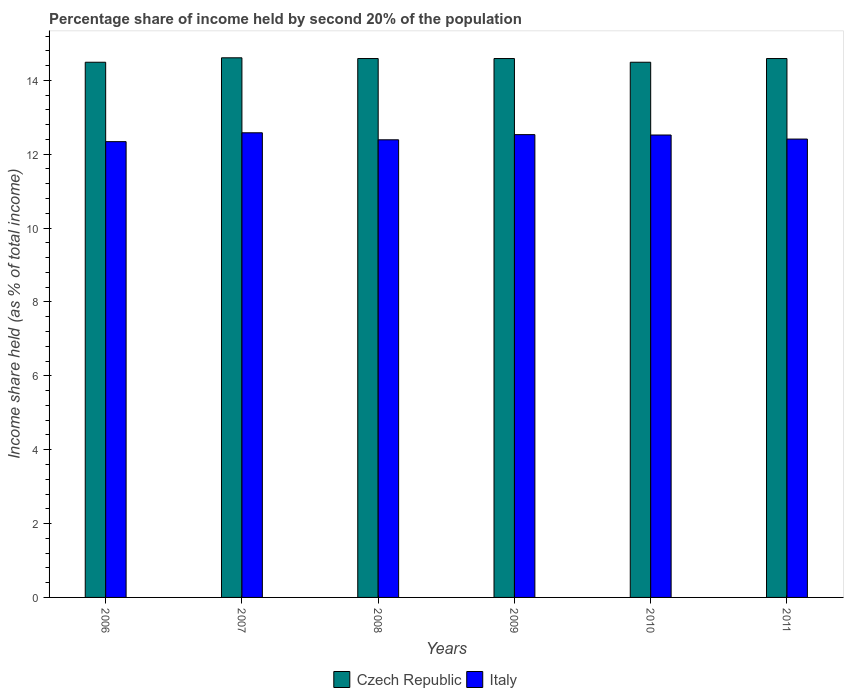How many different coloured bars are there?
Your answer should be compact. 2. How many groups of bars are there?
Keep it short and to the point. 6. Are the number of bars per tick equal to the number of legend labels?
Make the answer very short. Yes. How many bars are there on the 3rd tick from the right?
Ensure brevity in your answer.  2. What is the share of income held by second 20% of the population in Italy in 2011?
Your response must be concise. 12.41. Across all years, what is the maximum share of income held by second 20% of the population in Czech Republic?
Give a very brief answer. 14.61. Across all years, what is the minimum share of income held by second 20% of the population in Italy?
Offer a very short reply. 12.34. In which year was the share of income held by second 20% of the population in Italy maximum?
Provide a succinct answer. 2007. What is the total share of income held by second 20% of the population in Czech Republic in the graph?
Your answer should be compact. 87.36. What is the difference between the share of income held by second 20% of the population in Czech Republic in 2010 and the share of income held by second 20% of the population in Italy in 2006?
Give a very brief answer. 2.15. What is the average share of income held by second 20% of the population in Italy per year?
Give a very brief answer. 12.46. In the year 2007, what is the difference between the share of income held by second 20% of the population in Italy and share of income held by second 20% of the population in Czech Republic?
Make the answer very short. -2.03. In how many years, is the share of income held by second 20% of the population in Italy greater than 1.2000000000000002 %?
Provide a succinct answer. 6. What is the ratio of the share of income held by second 20% of the population in Czech Republic in 2008 to that in 2009?
Offer a very short reply. 1. Is the share of income held by second 20% of the population in Czech Republic in 2008 less than that in 2010?
Your answer should be compact. No. Is the difference between the share of income held by second 20% of the population in Italy in 2007 and 2010 greater than the difference between the share of income held by second 20% of the population in Czech Republic in 2007 and 2010?
Your answer should be compact. No. What is the difference between the highest and the second highest share of income held by second 20% of the population in Czech Republic?
Offer a terse response. 0.02. What is the difference between the highest and the lowest share of income held by second 20% of the population in Czech Republic?
Offer a very short reply. 0.12. What does the 2nd bar from the left in 2009 represents?
Keep it short and to the point. Italy. What does the 2nd bar from the right in 2006 represents?
Your response must be concise. Czech Republic. How many bars are there?
Offer a terse response. 12. Are all the bars in the graph horizontal?
Offer a terse response. No. Are the values on the major ticks of Y-axis written in scientific E-notation?
Give a very brief answer. No. Does the graph contain any zero values?
Provide a succinct answer. No. Does the graph contain grids?
Provide a short and direct response. No. How many legend labels are there?
Provide a short and direct response. 2. How are the legend labels stacked?
Offer a terse response. Horizontal. What is the title of the graph?
Make the answer very short. Percentage share of income held by second 20% of the population. Does "Nigeria" appear as one of the legend labels in the graph?
Your response must be concise. No. What is the label or title of the Y-axis?
Make the answer very short. Income share held (as % of total income). What is the Income share held (as % of total income) of Czech Republic in 2006?
Provide a succinct answer. 14.49. What is the Income share held (as % of total income) in Italy in 2006?
Offer a terse response. 12.34. What is the Income share held (as % of total income) of Czech Republic in 2007?
Your response must be concise. 14.61. What is the Income share held (as % of total income) of Italy in 2007?
Provide a short and direct response. 12.58. What is the Income share held (as % of total income) in Czech Republic in 2008?
Ensure brevity in your answer.  14.59. What is the Income share held (as % of total income) in Italy in 2008?
Your answer should be compact. 12.39. What is the Income share held (as % of total income) of Czech Republic in 2009?
Keep it short and to the point. 14.59. What is the Income share held (as % of total income) in Italy in 2009?
Provide a short and direct response. 12.53. What is the Income share held (as % of total income) in Czech Republic in 2010?
Provide a short and direct response. 14.49. What is the Income share held (as % of total income) in Italy in 2010?
Make the answer very short. 12.52. What is the Income share held (as % of total income) in Czech Republic in 2011?
Provide a succinct answer. 14.59. What is the Income share held (as % of total income) in Italy in 2011?
Make the answer very short. 12.41. Across all years, what is the maximum Income share held (as % of total income) of Czech Republic?
Your answer should be very brief. 14.61. Across all years, what is the maximum Income share held (as % of total income) in Italy?
Your answer should be compact. 12.58. Across all years, what is the minimum Income share held (as % of total income) of Czech Republic?
Offer a very short reply. 14.49. Across all years, what is the minimum Income share held (as % of total income) of Italy?
Ensure brevity in your answer.  12.34. What is the total Income share held (as % of total income) in Czech Republic in the graph?
Ensure brevity in your answer.  87.36. What is the total Income share held (as % of total income) in Italy in the graph?
Your answer should be very brief. 74.77. What is the difference between the Income share held (as % of total income) in Czech Republic in 2006 and that in 2007?
Offer a very short reply. -0.12. What is the difference between the Income share held (as % of total income) in Italy in 2006 and that in 2007?
Your answer should be compact. -0.24. What is the difference between the Income share held (as % of total income) in Italy in 2006 and that in 2008?
Give a very brief answer. -0.05. What is the difference between the Income share held (as % of total income) of Czech Republic in 2006 and that in 2009?
Give a very brief answer. -0.1. What is the difference between the Income share held (as % of total income) in Italy in 2006 and that in 2009?
Offer a terse response. -0.19. What is the difference between the Income share held (as % of total income) of Italy in 2006 and that in 2010?
Your answer should be compact. -0.18. What is the difference between the Income share held (as % of total income) in Czech Republic in 2006 and that in 2011?
Make the answer very short. -0.1. What is the difference between the Income share held (as % of total income) in Italy in 2006 and that in 2011?
Ensure brevity in your answer.  -0.07. What is the difference between the Income share held (as % of total income) in Czech Republic in 2007 and that in 2008?
Your answer should be compact. 0.02. What is the difference between the Income share held (as % of total income) of Italy in 2007 and that in 2008?
Your answer should be compact. 0.19. What is the difference between the Income share held (as % of total income) in Czech Republic in 2007 and that in 2009?
Offer a terse response. 0.02. What is the difference between the Income share held (as % of total income) in Czech Republic in 2007 and that in 2010?
Provide a short and direct response. 0.12. What is the difference between the Income share held (as % of total income) in Czech Republic in 2007 and that in 2011?
Offer a terse response. 0.02. What is the difference between the Income share held (as % of total income) in Italy in 2007 and that in 2011?
Your answer should be very brief. 0.17. What is the difference between the Income share held (as % of total income) in Czech Republic in 2008 and that in 2009?
Your answer should be compact. 0. What is the difference between the Income share held (as % of total income) of Italy in 2008 and that in 2009?
Provide a short and direct response. -0.14. What is the difference between the Income share held (as % of total income) in Italy in 2008 and that in 2010?
Offer a terse response. -0.13. What is the difference between the Income share held (as % of total income) in Italy in 2008 and that in 2011?
Your answer should be very brief. -0.02. What is the difference between the Income share held (as % of total income) of Czech Republic in 2009 and that in 2010?
Give a very brief answer. 0.1. What is the difference between the Income share held (as % of total income) in Italy in 2009 and that in 2010?
Provide a short and direct response. 0.01. What is the difference between the Income share held (as % of total income) of Czech Republic in 2009 and that in 2011?
Provide a succinct answer. 0. What is the difference between the Income share held (as % of total income) of Italy in 2009 and that in 2011?
Make the answer very short. 0.12. What is the difference between the Income share held (as % of total income) of Italy in 2010 and that in 2011?
Offer a terse response. 0.11. What is the difference between the Income share held (as % of total income) of Czech Republic in 2006 and the Income share held (as % of total income) of Italy in 2007?
Keep it short and to the point. 1.91. What is the difference between the Income share held (as % of total income) of Czech Republic in 2006 and the Income share held (as % of total income) of Italy in 2009?
Your answer should be very brief. 1.96. What is the difference between the Income share held (as % of total income) of Czech Republic in 2006 and the Income share held (as % of total income) of Italy in 2010?
Offer a terse response. 1.97. What is the difference between the Income share held (as % of total income) in Czech Republic in 2006 and the Income share held (as % of total income) in Italy in 2011?
Offer a terse response. 2.08. What is the difference between the Income share held (as % of total income) in Czech Republic in 2007 and the Income share held (as % of total income) in Italy in 2008?
Give a very brief answer. 2.22. What is the difference between the Income share held (as % of total income) of Czech Republic in 2007 and the Income share held (as % of total income) of Italy in 2009?
Provide a succinct answer. 2.08. What is the difference between the Income share held (as % of total income) of Czech Republic in 2007 and the Income share held (as % of total income) of Italy in 2010?
Make the answer very short. 2.09. What is the difference between the Income share held (as % of total income) of Czech Republic in 2008 and the Income share held (as % of total income) of Italy in 2009?
Provide a short and direct response. 2.06. What is the difference between the Income share held (as % of total income) in Czech Republic in 2008 and the Income share held (as % of total income) in Italy in 2010?
Provide a succinct answer. 2.07. What is the difference between the Income share held (as % of total income) in Czech Republic in 2008 and the Income share held (as % of total income) in Italy in 2011?
Give a very brief answer. 2.18. What is the difference between the Income share held (as % of total income) in Czech Republic in 2009 and the Income share held (as % of total income) in Italy in 2010?
Ensure brevity in your answer.  2.07. What is the difference between the Income share held (as % of total income) in Czech Republic in 2009 and the Income share held (as % of total income) in Italy in 2011?
Make the answer very short. 2.18. What is the difference between the Income share held (as % of total income) in Czech Republic in 2010 and the Income share held (as % of total income) in Italy in 2011?
Your answer should be compact. 2.08. What is the average Income share held (as % of total income) in Czech Republic per year?
Give a very brief answer. 14.56. What is the average Income share held (as % of total income) in Italy per year?
Make the answer very short. 12.46. In the year 2006, what is the difference between the Income share held (as % of total income) in Czech Republic and Income share held (as % of total income) in Italy?
Your answer should be very brief. 2.15. In the year 2007, what is the difference between the Income share held (as % of total income) in Czech Republic and Income share held (as % of total income) in Italy?
Ensure brevity in your answer.  2.03. In the year 2008, what is the difference between the Income share held (as % of total income) of Czech Republic and Income share held (as % of total income) of Italy?
Give a very brief answer. 2.2. In the year 2009, what is the difference between the Income share held (as % of total income) of Czech Republic and Income share held (as % of total income) of Italy?
Offer a terse response. 2.06. In the year 2010, what is the difference between the Income share held (as % of total income) of Czech Republic and Income share held (as % of total income) of Italy?
Your answer should be compact. 1.97. In the year 2011, what is the difference between the Income share held (as % of total income) of Czech Republic and Income share held (as % of total income) of Italy?
Ensure brevity in your answer.  2.18. What is the ratio of the Income share held (as % of total income) of Czech Republic in 2006 to that in 2007?
Provide a succinct answer. 0.99. What is the ratio of the Income share held (as % of total income) in Italy in 2006 to that in 2007?
Provide a short and direct response. 0.98. What is the ratio of the Income share held (as % of total income) of Czech Republic in 2006 to that in 2008?
Your response must be concise. 0.99. What is the ratio of the Income share held (as % of total income) of Czech Republic in 2006 to that in 2009?
Your answer should be compact. 0.99. What is the ratio of the Income share held (as % of total income) of Italy in 2006 to that in 2009?
Your answer should be compact. 0.98. What is the ratio of the Income share held (as % of total income) of Italy in 2006 to that in 2010?
Keep it short and to the point. 0.99. What is the ratio of the Income share held (as % of total income) of Czech Republic in 2006 to that in 2011?
Provide a short and direct response. 0.99. What is the ratio of the Income share held (as % of total income) of Italy in 2007 to that in 2008?
Ensure brevity in your answer.  1.02. What is the ratio of the Income share held (as % of total income) of Italy in 2007 to that in 2009?
Make the answer very short. 1. What is the ratio of the Income share held (as % of total income) of Czech Republic in 2007 to that in 2010?
Ensure brevity in your answer.  1.01. What is the ratio of the Income share held (as % of total income) of Italy in 2007 to that in 2011?
Keep it short and to the point. 1.01. What is the ratio of the Income share held (as % of total income) of Italy in 2008 to that in 2009?
Offer a terse response. 0.99. What is the ratio of the Income share held (as % of total income) in Italy in 2008 to that in 2010?
Your response must be concise. 0.99. What is the ratio of the Income share held (as % of total income) of Italy in 2008 to that in 2011?
Your answer should be compact. 1. What is the ratio of the Income share held (as % of total income) of Czech Republic in 2009 to that in 2010?
Give a very brief answer. 1.01. What is the ratio of the Income share held (as % of total income) of Italy in 2009 to that in 2010?
Ensure brevity in your answer.  1. What is the ratio of the Income share held (as % of total income) in Italy in 2009 to that in 2011?
Provide a succinct answer. 1.01. What is the ratio of the Income share held (as % of total income) of Italy in 2010 to that in 2011?
Your response must be concise. 1.01. What is the difference between the highest and the lowest Income share held (as % of total income) in Czech Republic?
Offer a very short reply. 0.12. What is the difference between the highest and the lowest Income share held (as % of total income) of Italy?
Offer a terse response. 0.24. 